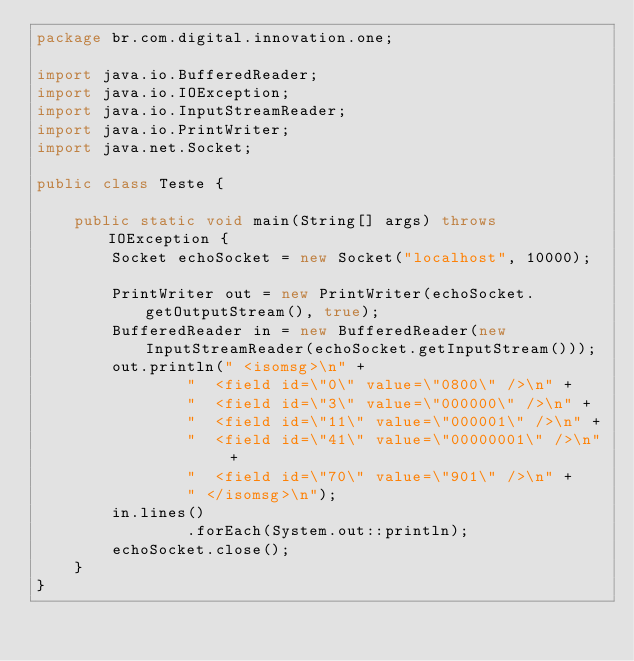<code> <loc_0><loc_0><loc_500><loc_500><_Java_>package br.com.digital.innovation.one;

import java.io.BufferedReader;
import java.io.IOException;
import java.io.InputStreamReader;
import java.io.PrintWriter;
import java.net.Socket;

public class Teste {

    public static void main(String[] args) throws IOException {
        Socket echoSocket = new Socket("localhost", 10000);

        PrintWriter out = new PrintWriter(echoSocket.getOutputStream(), true);
        BufferedReader in = new BufferedReader(new InputStreamReader(echoSocket.getInputStream()));
        out.println(" <isomsg>\n" +
                "  <field id=\"0\" value=\"0800\" />\n" +
                "  <field id=\"3\" value=\"000000\" />\n" +
                "  <field id=\"11\" value=\"000001\" />\n" +
                "  <field id=\"41\" value=\"00000001\" />\n" +
                "  <field id=\"70\" value=\"901\" />\n" +
                " </isomsg>\n");
        in.lines()
                .forEach(System.out::println);
        echoSocket.close();
    }
}
</code> 